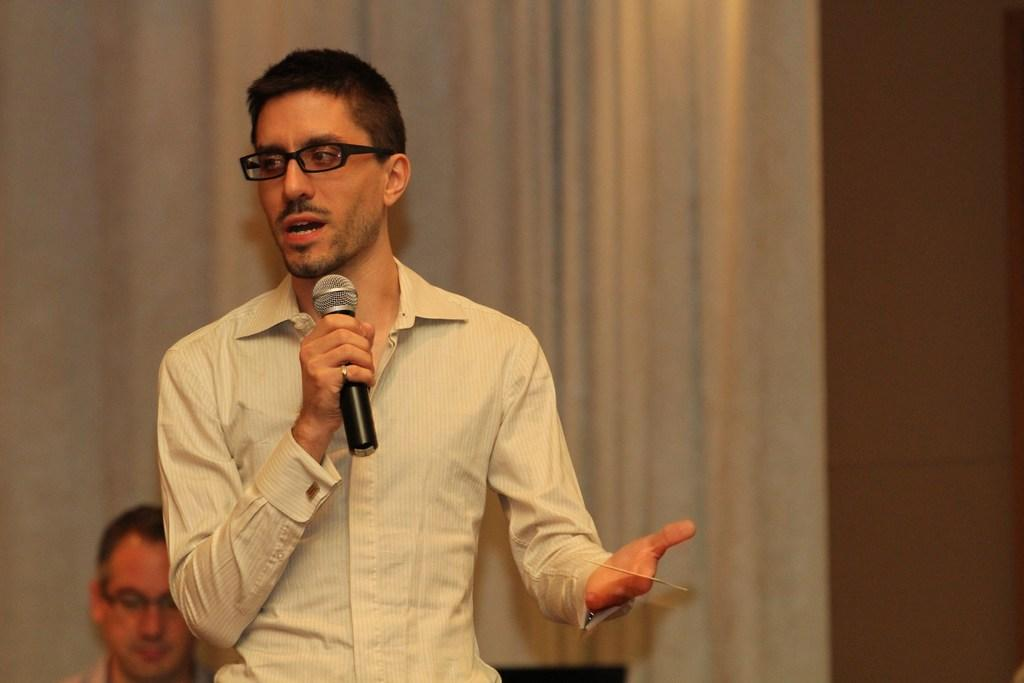What is the man in the image holding? The man is holding a mic. Can you describe the man's position in the image? The man is standing in the image. Are there any other people visible in the image? Yes, there is another man visible on the backside of the image. What can be seen in the background of the image? There is a curtain and a wall in the image. What type of sugar is being used to sweeten the feather in the image? There is no sugar or feather present in the image. 